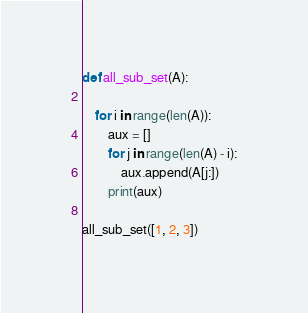Convert code to text. <code><loc_0><loc_0><loc_500><loc_500><_Python_>
def all_sub_set(A):
    
    for i in range(len(A)):
        aux = []
        for j in range(len(A) - i):
            aux.append(A[j:])
        print(aux)

all_sub_set([1, 2, 3])
</code> 